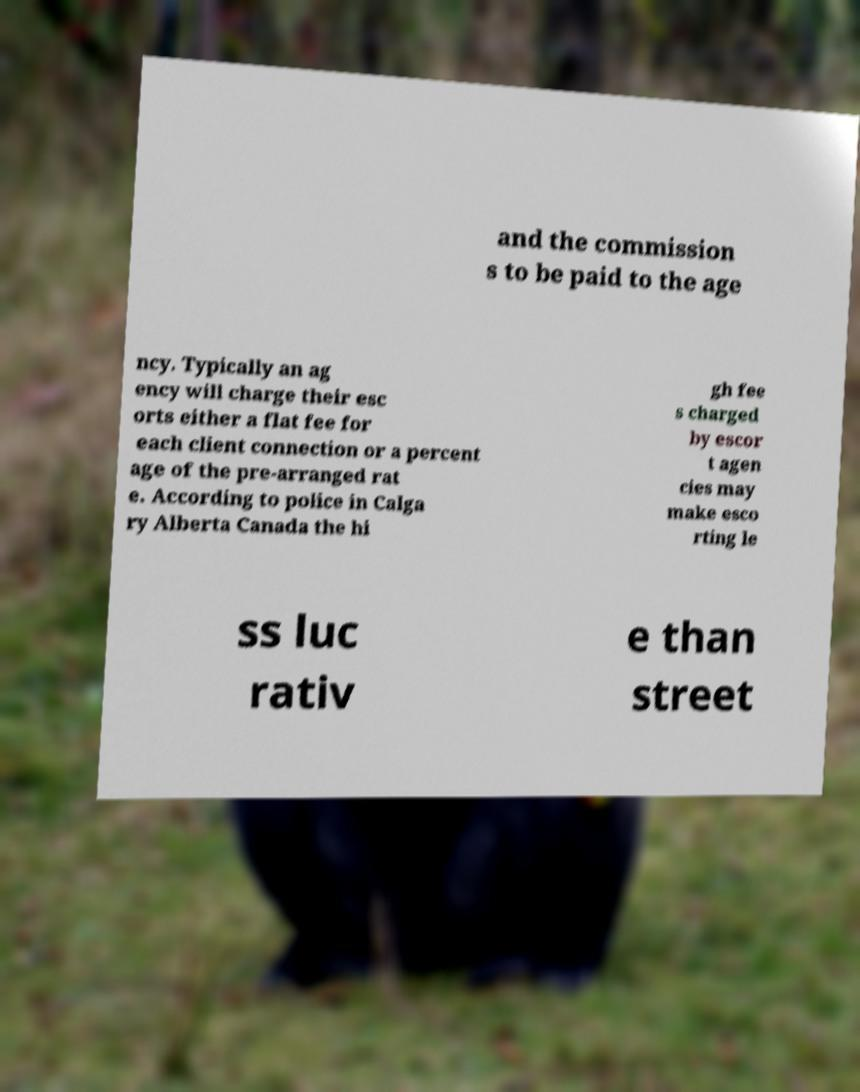I need the written content from this picture converted into text. Can you do that? and the commission s to be paid to the age ncy. Typically an ag ency will charge their esc orts either a flat fee for each client connection or a percent age of the pre-arranged rat e. According to police in Calga ry Alberta Canada the hi gh fee s charged by escor t agen cies may make esco rting le ss luc rativ e than street 